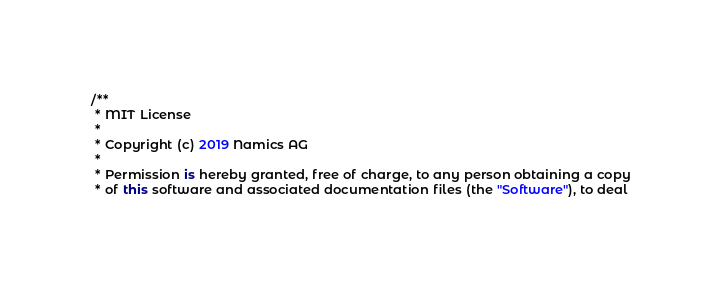<code> <loc_0><loc_0><loc_500><loc_500><_Kotlin_>/**
 * MIT License
 *
 * Copyright (c) 2019 Namics AG
 *
 * Permission is hereby granted, free of charge, to any person obtaining a copy
 * of this software and associated documentation files (the "Software"), to deal</code> 